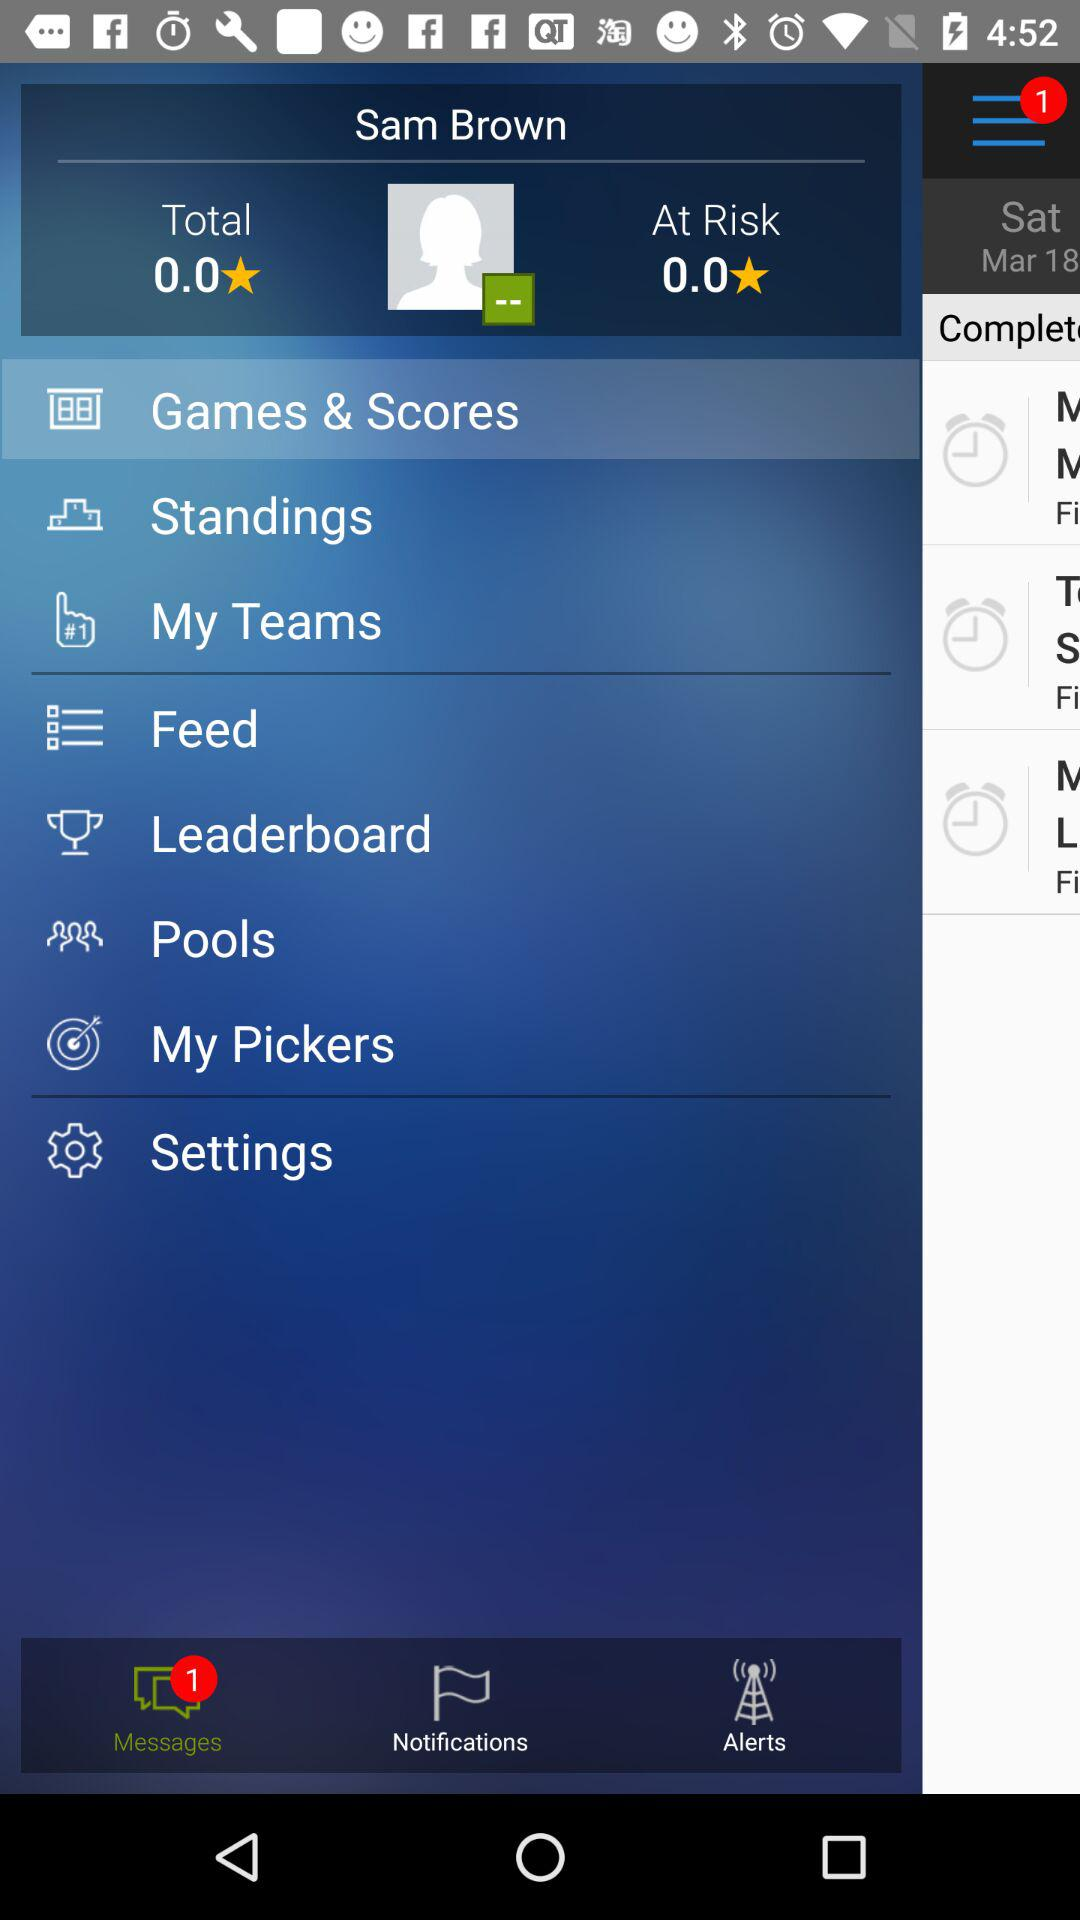How many unread messages do we have? You have 1 unread message. 